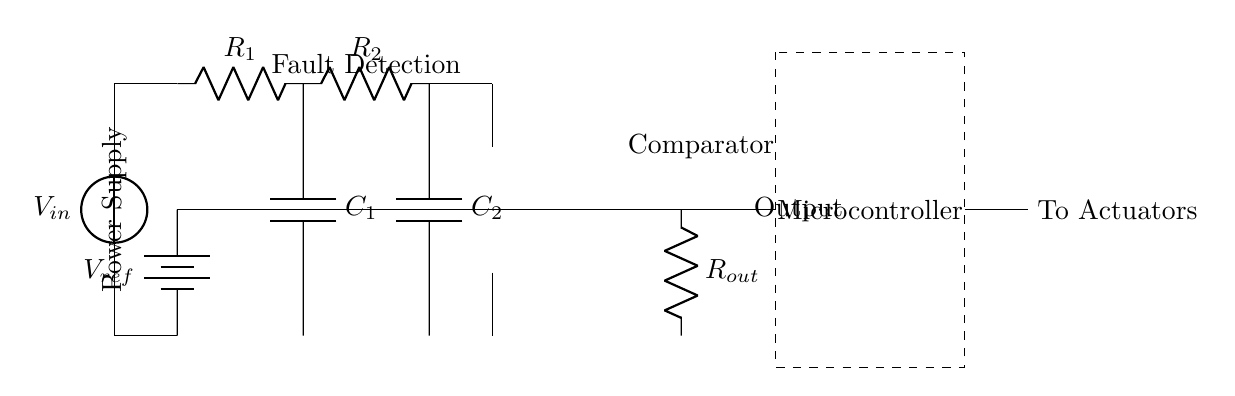What is the type of power supply used in this circuit? The circuit diagram shows a voltage source labeled as V_in, which indicates that the circuit uses a DC power supply.
Answer: DC power supply What component is responsible for fault detection? The fault detection is indicated by the resistor and capacitor arrangement, primarily showing R1, C1, R2, and C2, which function together to sense faults.
Answer: Resistors and capacitors What is the output from the comparator in this circuit? The comparator's output is connected to resistor R_out, which implies it processes the fault detection signals to produce an output voltage or logic level.
Answer: Voltage/output How many capacitors are present in the circuit? By observing the diagram, there are two capacitors labeled as C1 and C2, which are clearly marked and part of the fault detection circuit.
Answer: Two capacitors What is the reference voltage in this circuit? The circuit includes a voltage reference labeled as V_ref, which is supplied to the comparator for accurate measurement against the input signal.
Answer: V_ref What role does the microcontroller serve in this circuit? The microcontroller is positioned after the output of the comparator and is responsible for processing the output signal and making decisions based on the fault detection data.
Answer: Processing/decision-making Which signal does the output of the circuit go to? The output from R_out is indicated to connect to actuators, which are implied to be the components that will be controlled based on the fault conditions detected.
Answer: Actuators 